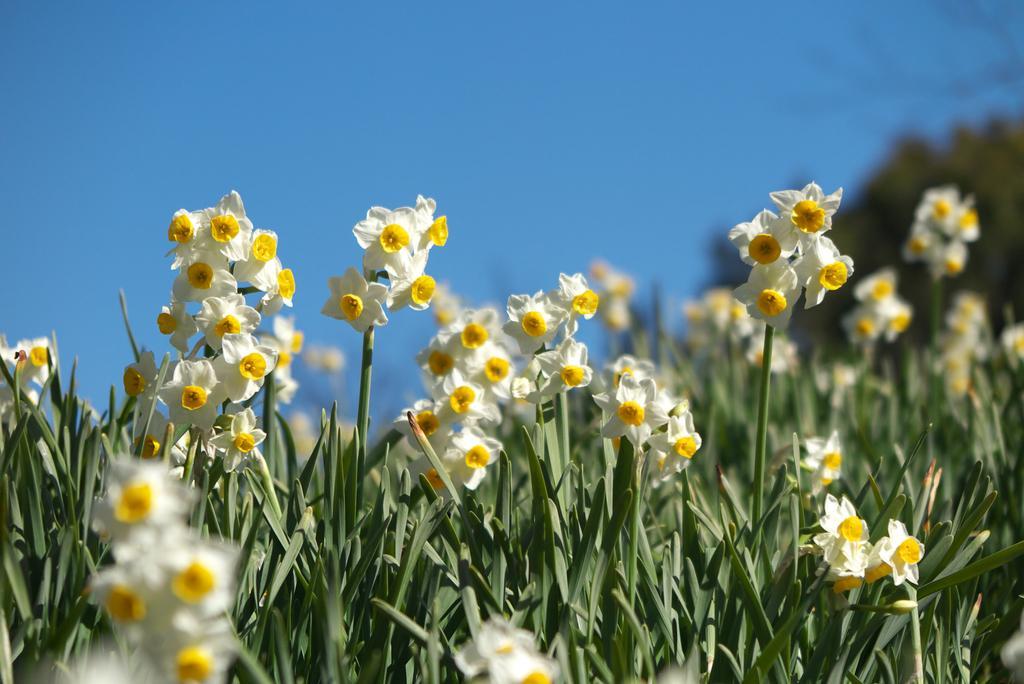Please provide a concise description of this image. In this image I can see there is some grass and plants, I can see there are few white flowers and the sky is clear. 